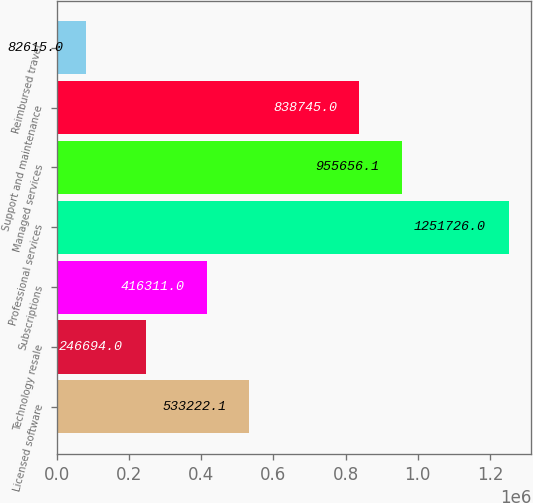Convert chart. <chart><loc_0><loc_0><loc_500><loc_500><bar_chart><fcel>Licensed software<fcel>Technology resale<fcel>Subscriptions<fcel>Professional services<fcel>Managed services<fcel>Support and maintenance<fcel>Reimbursed travel<nl><fcel>533222<fcel>246694<fcel>416311<fcel>1.25173e+06<fcel>955656<fcel>838745<fcel>82615<nl></chart> 